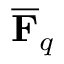Convert formula to latex. <formula><loc_0><loc_0><loc_500><loc_500>{ \overline { F } } _ { q }</formula> 